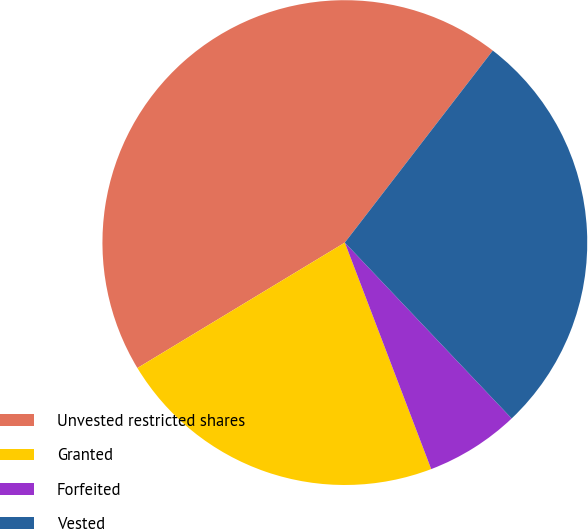Convert chart. <chart><loc_0><loc_0><loc_500><loc_500><pie_chart><fcel>Unvested restricted shares<fcel>Granted<fcel>Forfeited<fcel>Vested<nl><fcel>44.1%<fcel>22.14%<fcel>6.28%<fcel>27.47%<nl></chart> 